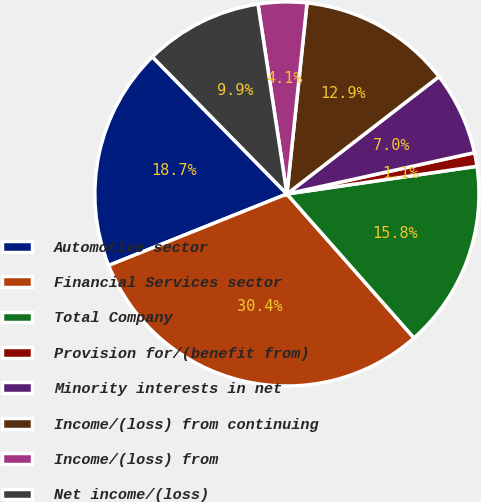<chart> <loc_0><loc_0><loc_500><loc_500><pie_chart><fcel>Automotive sector<fcel>Financial Services sector<fcel>Total Company<fcel>Provision for/(benefit from)<fcel>Minority interests in net<fcel>Income/(loss) from continuing<fcel>Income/(loss) from<fcel>Net income/(loss)<nl><fcel>18.72%<fcel>30.44%<fcel>15.79%<fcel>1.15%<fcel>7.01%<fcel>12.87%<fcel>4.08%<fcel>9.94%<nl></chart> 